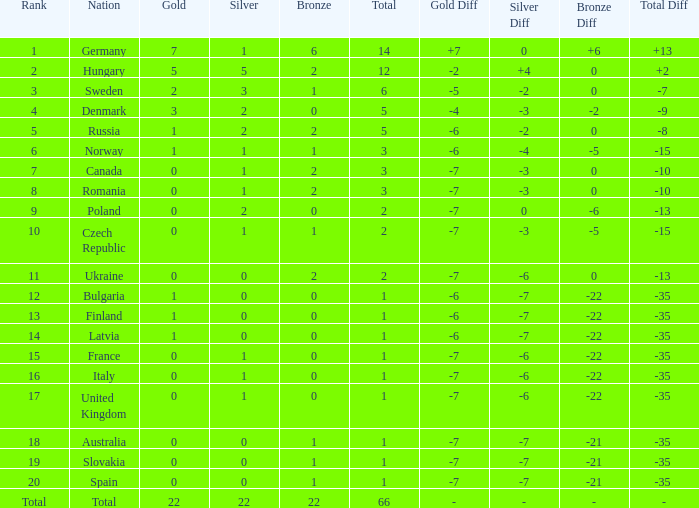What is the fewest number of silver medals won by Canada with fewer than 3 total medals? None. Could you parse the entire table? {'header': ['Rank', 'Nation', 'Gold', 'Silver', 'Bronze', 'Total', 'Gold Diff', 'Silver Diff', 'Bronze Diff', 'Total Diff'], 'rows': [['1', 'Germany', '7', '1', '6', '14', '+7', '0', '+6', '+13 '], ['2', 'Hungary', '5', '5', '2', '12', '-2', '+4', '0', '+2 '], ['3', 'Sweden', '2', '3', '1', '6', '-5', '-2', '0', '-7 '], ['4', 'Denmark', '3', '2', '0', '5', '-4', '-3', '-2', '-9 '], ['5', 'Russia', '1', '2', '2', '5', '-6', '-2', '0', '-8 '], ['6', 'Norway', '1', '1', '1', '3', '-6', '-4', '-5', '-15 '], ['7', 'Canada', '0', '1', '2', '3', '-7', '-3', '0', '-10 '], ['8', 'Romania', '0', '1', '2', '3', '-7', '-3', '0', '-10 '], ['9', 'Poland', '0', '2', '0', '2', '-7', '0', '-6', '-13 '], ['10', 'Czech Republic', '0', '1', '1', '2', '-7', '-3', '-5', '-15 '], ['11', 'Ukraine', '0', '0', '2', '2', '-7', '-6', '0', '-13 '], ['12', 'Bulgaria', '1', '0', '0', '1', '-6', '-7', '-22', '-35 '], ['13', 'Finland', '1', '0', '0', '1', '-6', '-7', '-22', '-35 '], ['14', 'Latvia', '1', '0', '0', '1', '-6', '-7', '-22', '-35 '], ['15', 'France', '0', '1', '0', '1', '-7', '-6', '-22', '-35 '], ['16', 'Italy', '0', '1', '0', '1', '-7', '-6', '-22', '-35 '], ['17', 'United Kingdom', '0', '1', '0', '1', '-7', '-6', '-22', '-35 '], ['18', 'Australia', '0', '0', '1', '1', '-7', '-7', '-21', '-35 '], ['19', 'Slovakia', '0', '0', '1', '1', '-7', '-7', '-21', '-35 '], ['20', 'Spain', '0', '0', '1', '1', '-7', '-7', '-21', '-35 '], ['Total', 'Total', '22', '22', '22', '66', '-', '-', '-', '-']]} 